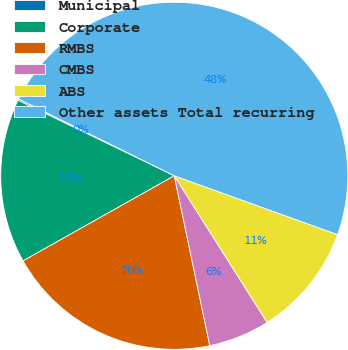Convert chart. <chart><loc_0><loc_0><loc_500><loc_500><pie_chart><fcel>Municipal<fcel>Corporate<fcel>RMBS<fcel>CMBS<fcel>ABS<fcel>Other assets Total recurring<nl><fcel>0.14%<fcel>15.32%<fcel>20.12%<fcel>5.71%<fcel>10.51%<fcel>48.2%<nl></chart> 